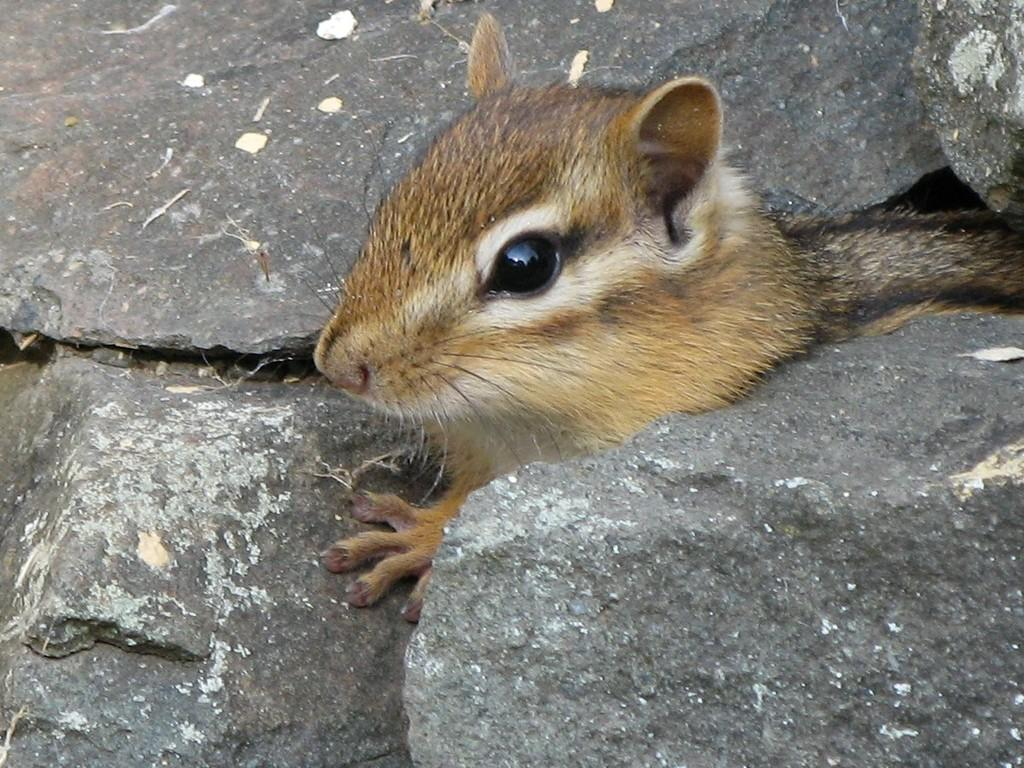What type of animal is in the image? There is a chipmunk in the image. Can you describe the color of the chipmunk? The chipmunk is light brown, white, and black in color. What else can be seen in the image besides the chipmunk? There are stones visible in the image. What type of suit is the chipmunk wearing in the image? There is no suit present in the image; the chipmunk is an animal and does not wear clothing. 